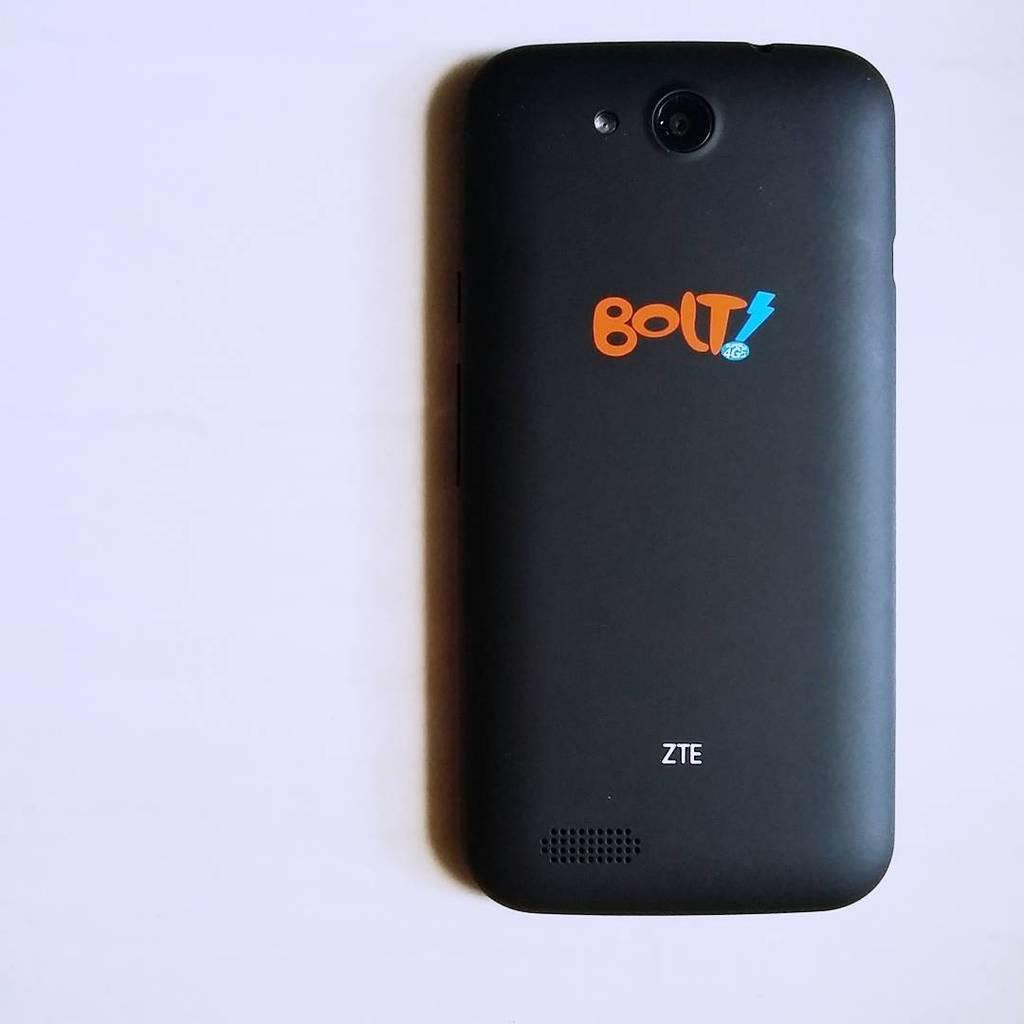<image>
Provide a brief description of the given image. A ZTE brand smart phone that says Bolt! on the back. 